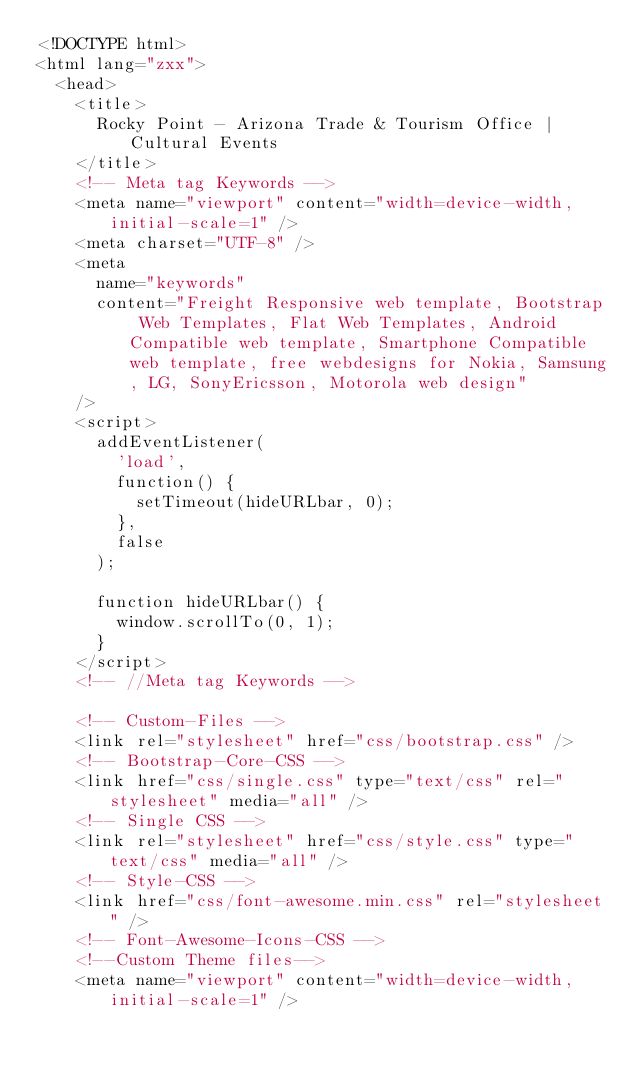Convert code to text. <code><loc_0><loc_0><loc_500><loc_500><_HTML_><!DOCTYPE html>
<html lang="zxx">
  <head>
    <title>
      Rocky Point - Arizona Trade & Tourism Office | Cultural Events
    </title>
    <!-- Meta tag Keywords -->
    <meta name="viewport" content="width=device-width, initial-scale=1" />
    <meta charset="UTF-8" />
    <meta
      name="keywords"
      content="Freight Responsive web template, Bootstrap Web Templates, Flat Web Templates, Android Compatible web template, Smartphone Compatible web template, free webdesigns for Nokia, Samsung, LG, SonyEricsson, Motorola web design"
    />
    <script>
      addEventListener(
        'load',
        function() {
          setTimeout(hideURLbar, 0);
        },
        false
      );

      function hideURLbar() {
        window.scrollTo(0, 1);
      }
    </script>
    <!-- //Meta tag Keywords -->

    <!-- Custom-Files -->
    <link rel="stylesheet" href="css/bootstrap.css" />
    <!-- Bootstrap-Core-CSS -->
    <link href="css/single.css" type="text/css" rel="stylesheet" media="all" />
    <!-- Single CSS -->
    <link rel="stylesheet" href="css/style.css" type="text/css" media="all" />
    <!-- Style-CSS -->
    <link href="css/font-awesome.min.css" rel="stylesheet" />
    <!-- Font-Awesome-Icons-CSS -->
    <!--Custom Theme files-->
    <meta name="viewport" content="width=device-width, initial-scale=1" /></code> 